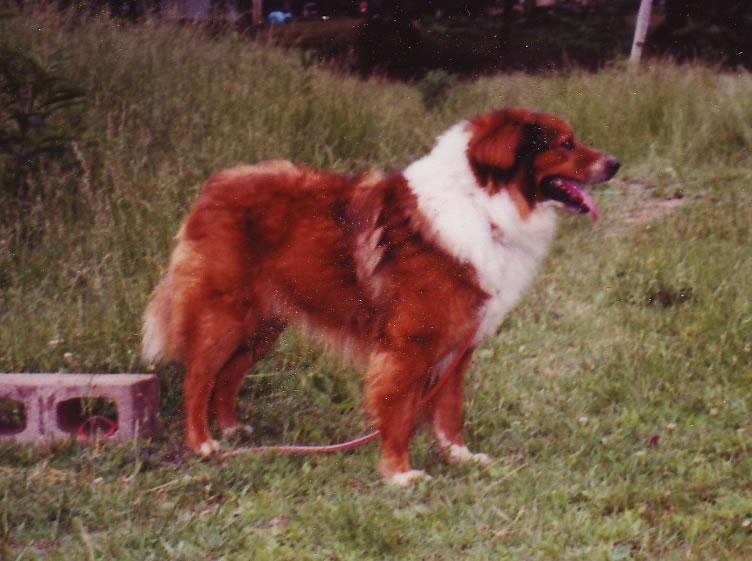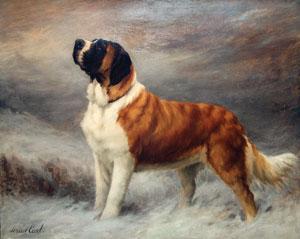The first image is the image on the left, the second image is the image on the right. Assess this claim about the two images: "One of the dogs is resting on the ground.". Correct or not? Answer yes or no. No. 